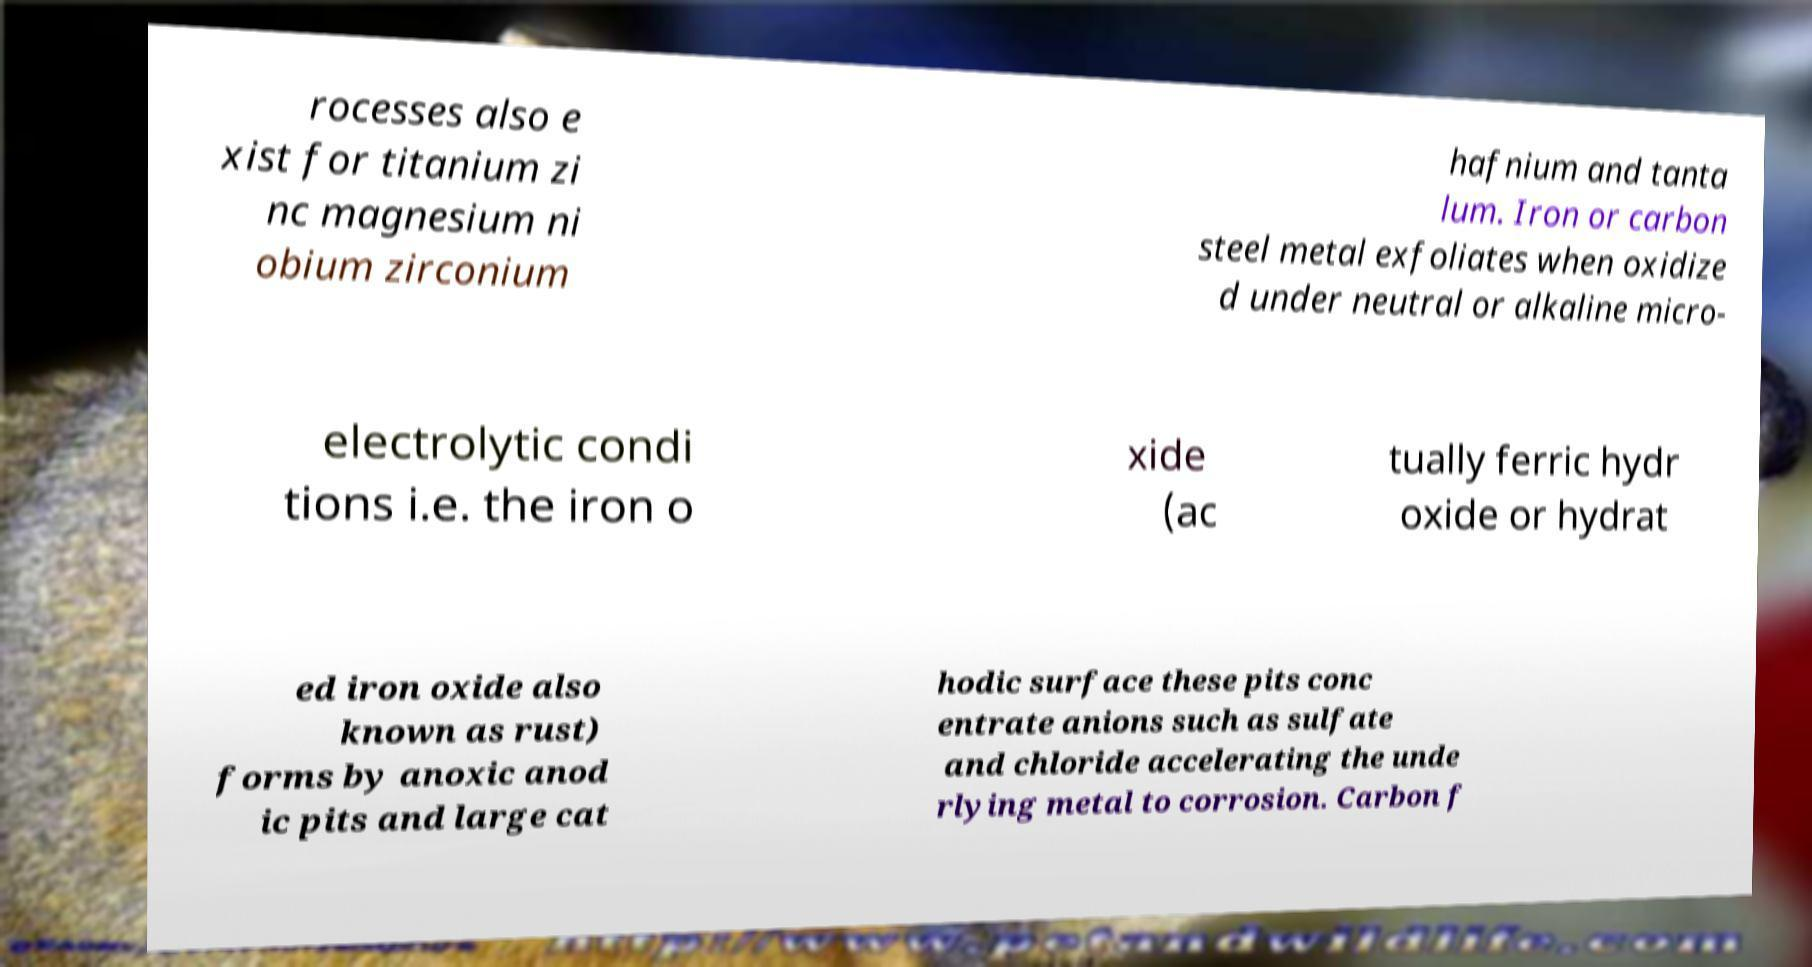I need the written content from this picture converted into text. Can you do that? rocesses also e xist for titanium zi nc magnesium ni obium zirconium hafnium and tanta lum. Iron or carbon steel metal exfoliates when oxidize d under neutral or alkaline micro- electrolytic condi tions i.e. the iron o xide (ac tually ferric hydr oxide or hydrat ed iron oxide also known as rust) forms by anoxic anod ic pits and large cat hodic surface these pits conc entrate anions such as sulfate and chloride accelerating the unde rlying metal to corrosion. Carbon f 